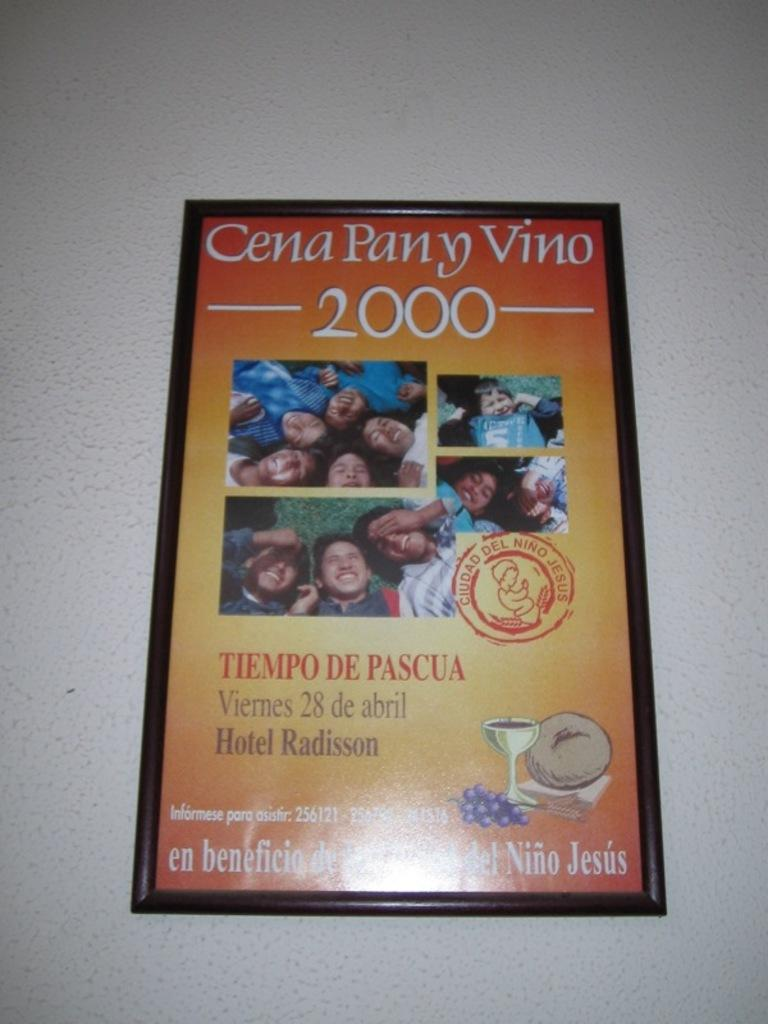Provide a one-sentence caption for the provided image. a framed picture advertising cena pany vino 2000. 